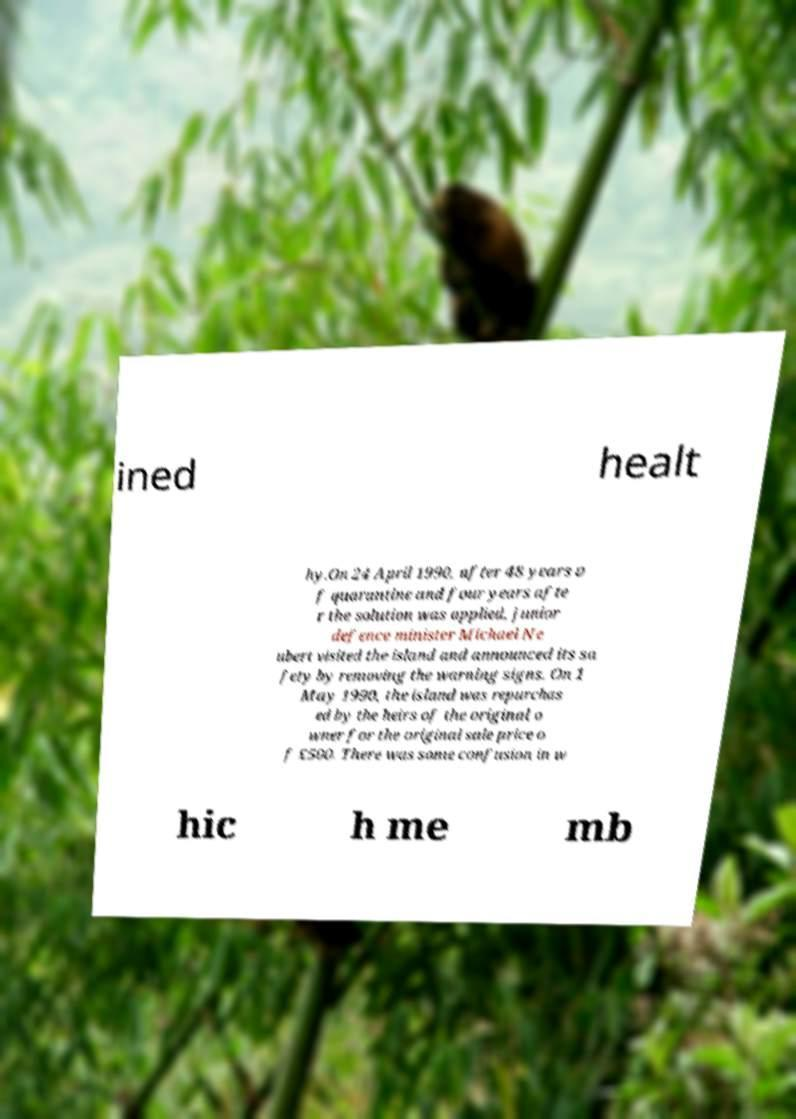There's text embedded in this image that I need extracted. Can you transcribe it verbatim? ined healt hy.On 24 April 1990, after 48 years o f quarantine and four years afte r the solution was applied, junior defence minister Michael Ne ubert visited the island and announced its sa fety by removing the warning signs. On 1 May 1990, the island was repurchas ed by the heirs of the original o wner for the original sale price o f £500. There was some confusion in w hic h me mb 